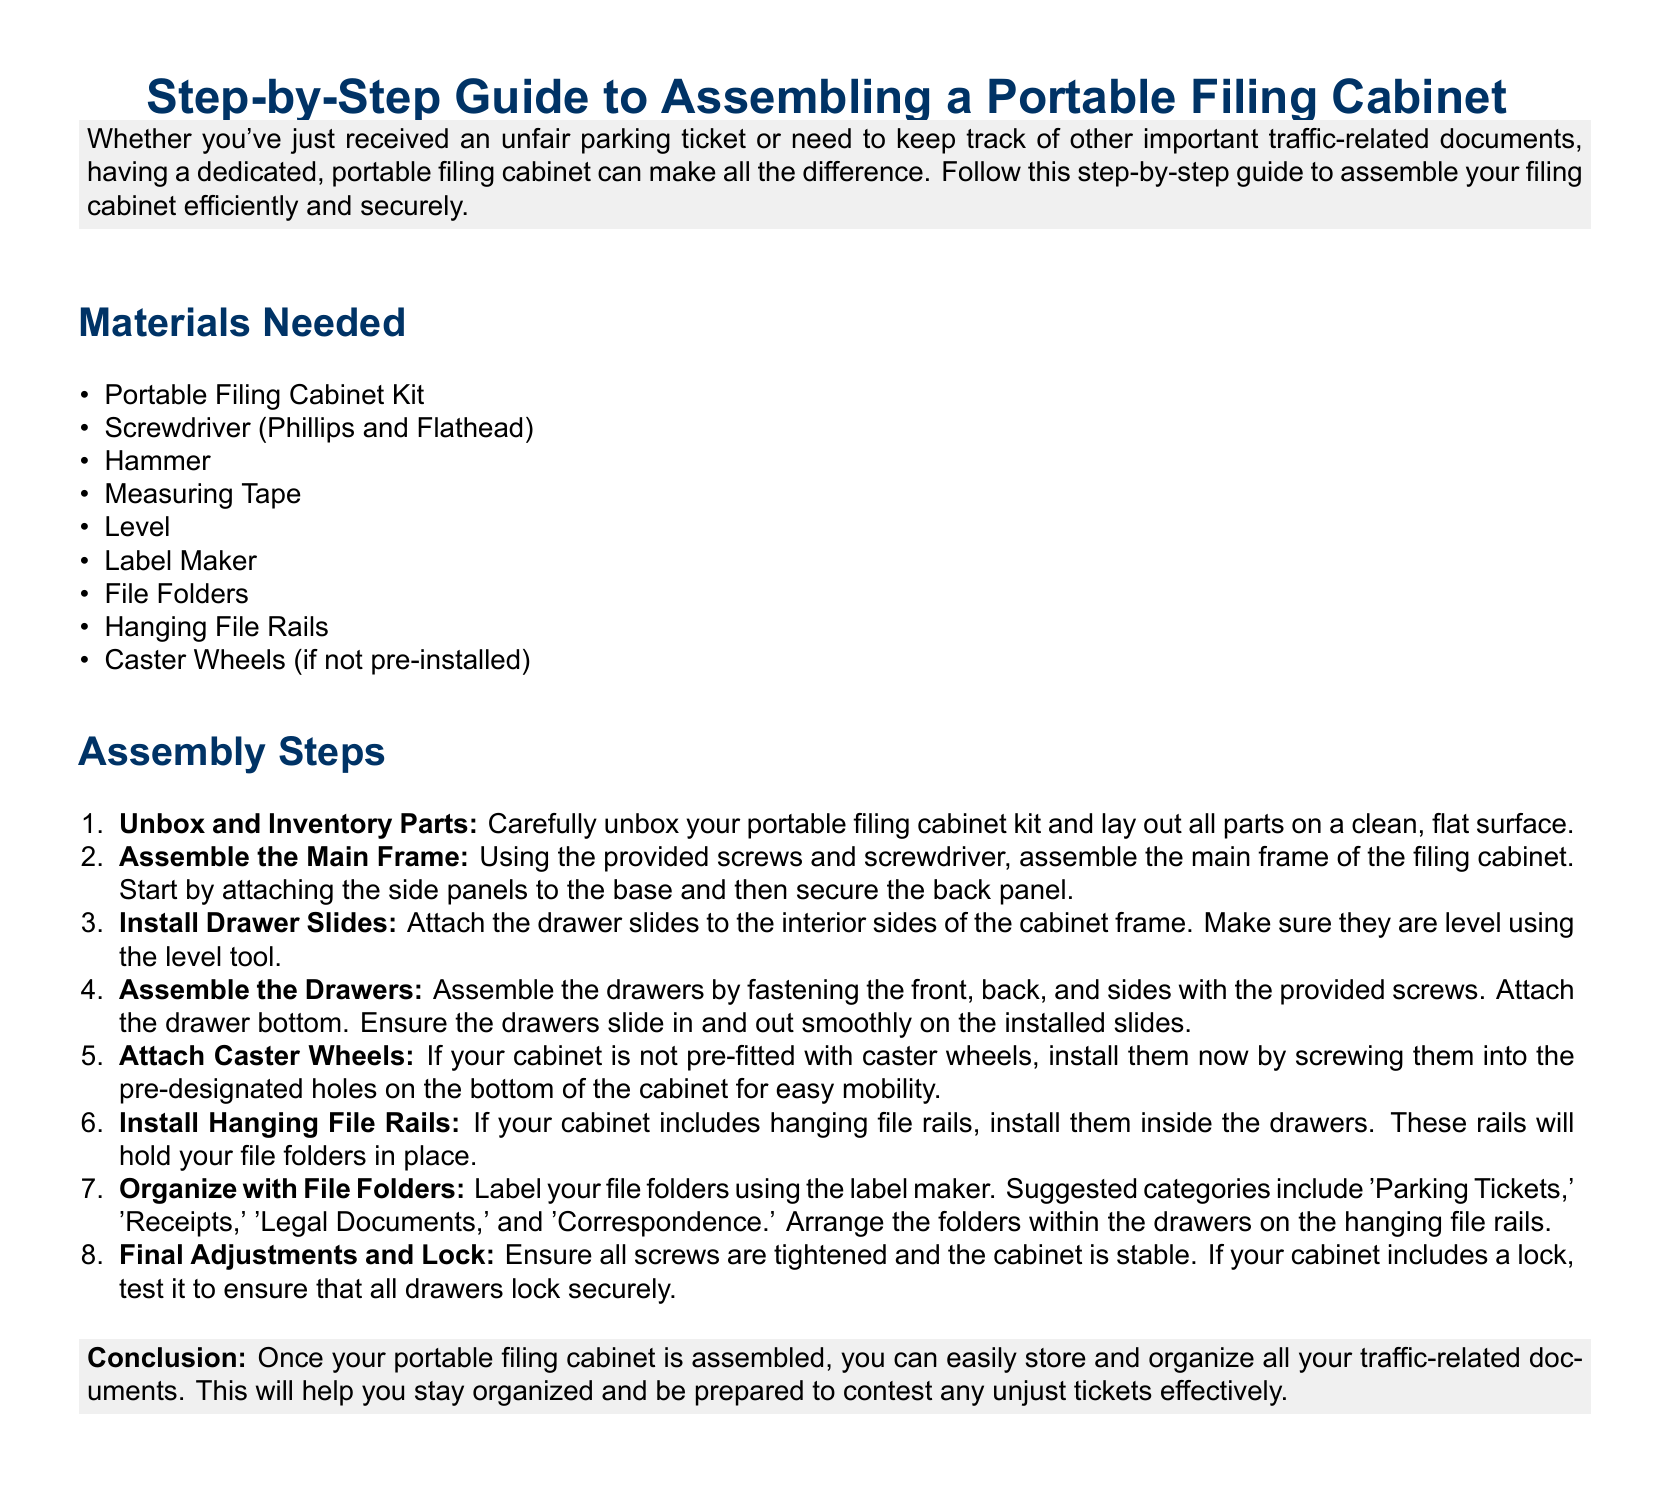What is the title of the guide? The title of the guide is stated at the beginning of the document.
Answer: Step-by-Step Guide to Assembling a Portable Filing Cabinet How many caster wheels are mentioned? The materials list specifies caster wheels if not pre-installed.
Answer: Caster Wheels What tool is used for tightening screws? The assembly steps refer to a screwdriver for this task.
Answer: Screwdriver Which category is suggested for labeling file folders related to parking? The document provides suggested categories for organizing documents.
Answer: Parking Tickets What is the main purpose of the portable filing cabinet? The introduction describes the purpose of having a filing cabinet.
Answer: Keeping traffic-related documents safe and organized What assembly step involves ensuring stability? The final assembly step mentions checking for stability.
Answer: Final Adjustments and Lock How many main assembly steps are outlined in the document? The assembly steps are presented in a numbered list.
Answer: Eight What should be checked in the last step of assembly? The last step highlights the importance of ensuring functionality.
Answer: Lock What is the color of the background in the document? The document explicitly mentions the color used for the page background.
Answer: White 